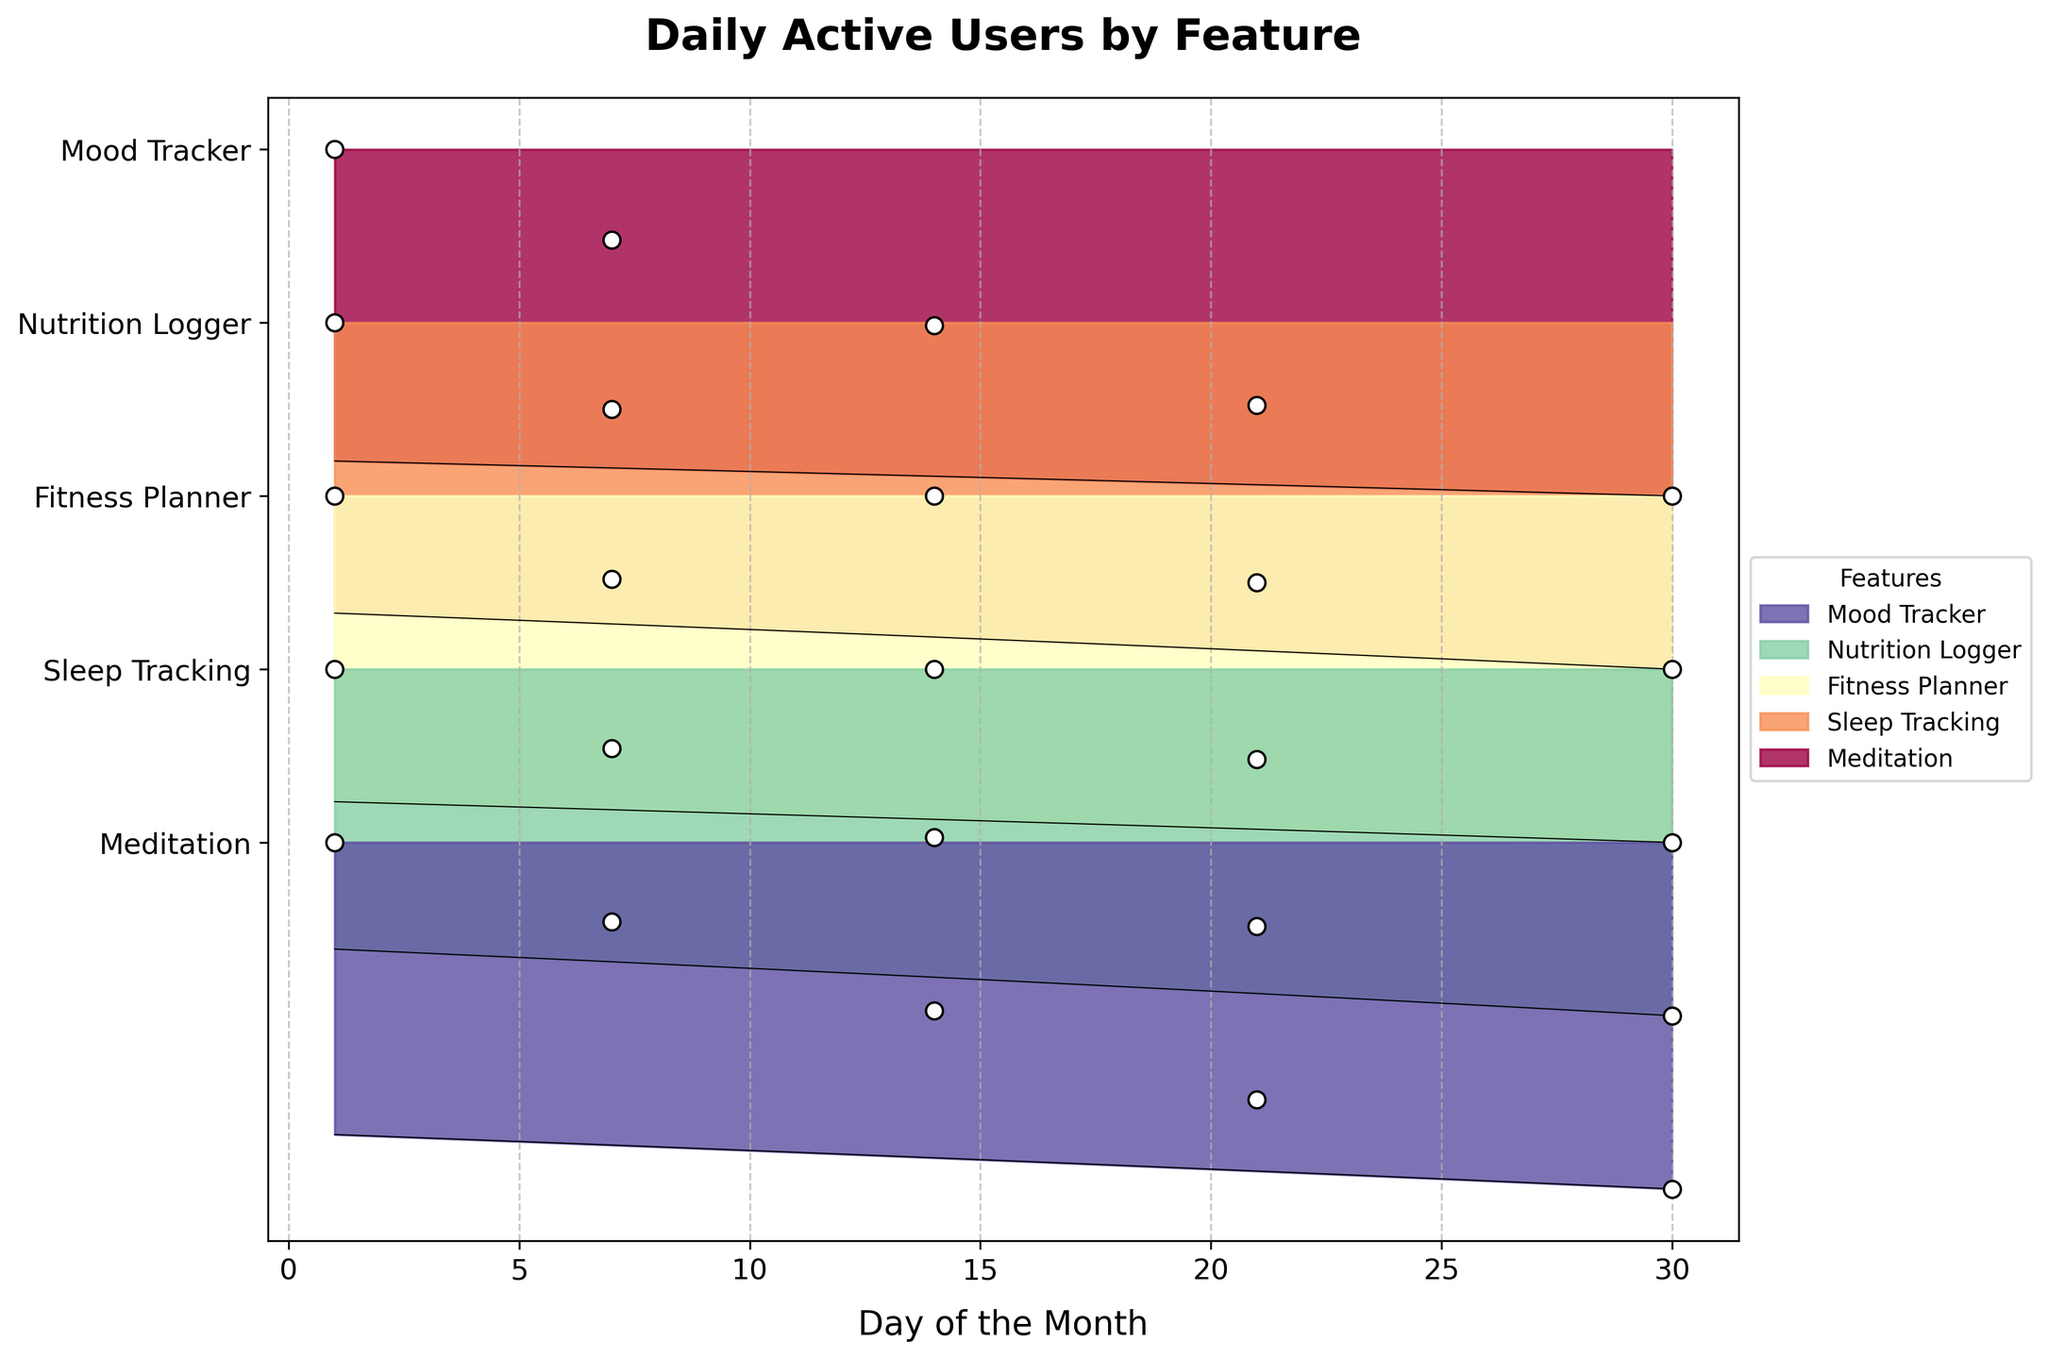What is the title of the plot? The title is usually displayed at the top of the figure. Here, it states "Daily Active Users by Feature".
Answer: Daily Active Users by Feature How are the y-axis labels organized? In the Ridgeline plot, the y-axis labels represent the various features of the wellness app and are arranged from top to bottom. The figure shows the labels from "Mood Tracker" at the top to "Meditation" at the bottom.
Answer: From "Mood Tracker" to "Meditation" What color palette is used for differentiating features in the plot? The plot uses a spectrum of colors from a gradient, specifically applying colors from the 'Spectral' colormap. Each feature has its own distinct color ranging from one end of the spectrum to the other.
Answer: Spectral colormap What is the highest number of daily active users observed for the Fitness Planner feature? By observing the y-axis level for Fitness Planner, the data points show the maximum number of users. The peak for Fitness Planner is shown on day 30, with 14,000 users.
Answer: 14000 Which feature has the highest number of daily users throughout the month, and what is the peak user count for that feature? To find this, we observe the highest y-axis level reached in the plot. "Sleep Tracking" reaches the highest user count on day 30 with 24,000 users.
Answer: Sleep Tracking, 24000 Which feature shows the most consistent growth in user count over the month? By comparing the scatter points and the ridgelines' gradient rise, "Meditation" shows a steady and consistent increase from day 1 to day 30 near 19,000 users.
Answer: Meditation How does the user count for "Mood Tracker" on day 30 compare to "Nutrition Logger" on the same day? Checking both the features' daily counts on day 30, "Mood Tracker" has 9,500 users, and "Nutrition Logger" has 11,000 users. "Nutrition Logger" has more users.
Answer: Nutrition Logger has more users Is there any feature that starts with fewer than 10,000 users on day 1 but exceeds that by day 30? By observing the scatter points, "Fitness Planner", "Nutrition Logger", and "Mood Tracker" all start below 10,000 on day 1 and exceed it by day 30.
Answer: Yes, Fitness Planner, Nutrition Logger, Mood Tracker What can you infer about the overall usage trend of the wellness app over the month? Examining the general shape of ridgelines and scatter points, all features show an increasing trend in user counts, indicating growing engagement with the app.
Answer: Increasing trend How does the variability of user counts for "Meditation" compare to "Sleep Tracking"? The width and height of density ridgelines indicate variability. "Meditation" has a narrow and consistent rise, while "Sleep Tracking" has a broader distribution, showing higher variability.
Answer: Sleep Tracking has higher variability Which day has the second-highest user count for all features combined? Summing up the user counts for all features day-wise, day 30 has the highest combined count and day 21 emerges as having the second-highest combined user count.
Answer: Day 21 